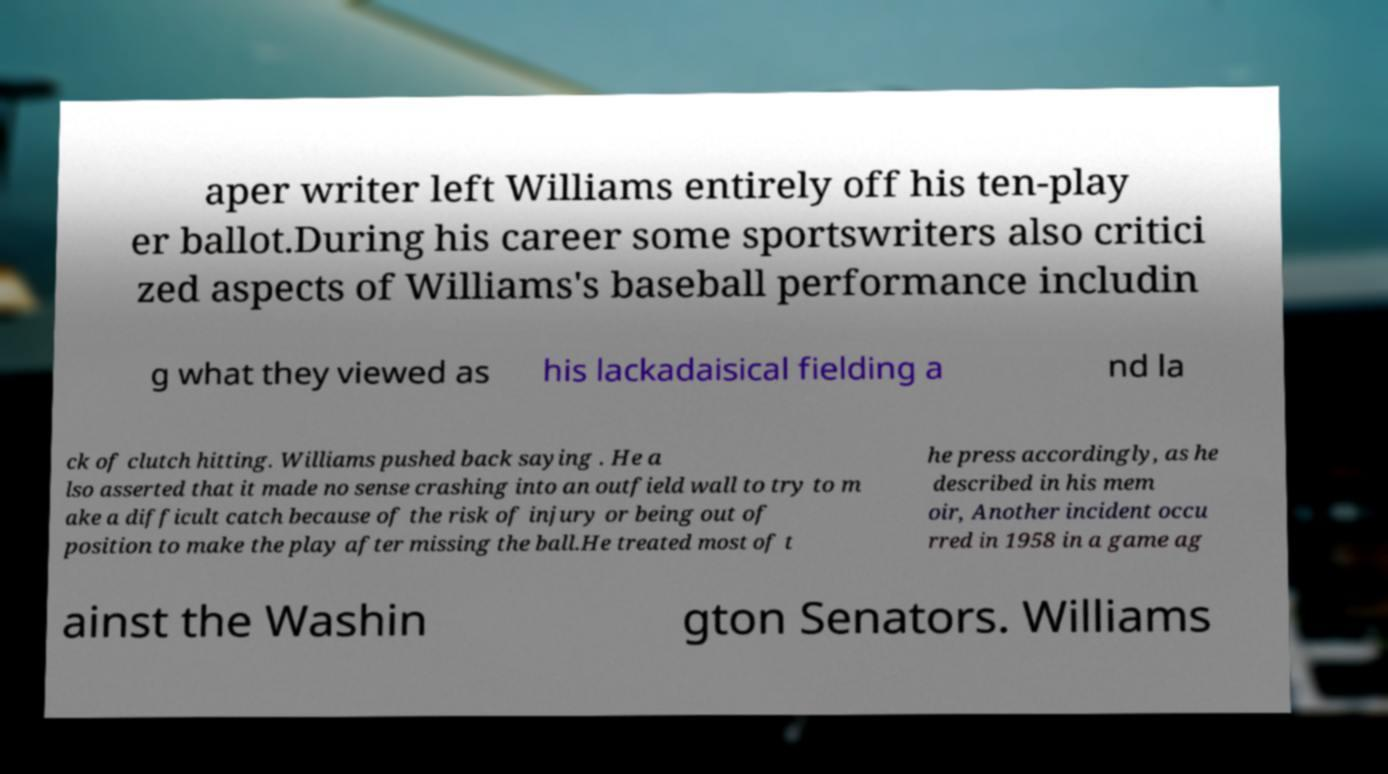Could you extract and type out the text from this image? aper writer left Williams entirely off his ten-play er ballot.During his career some sportswriters also critici zed aspects of Williams's baseball performance includin g what they viewed as his lackadaisical fielding a nd la ck of clutch hitting. Williams pushed back saying . He a lso asserted that it made no sense crashing into an outfield wall to try to m ake a difficult catch because of the risk of injury or being out of position to make the play after missing the ball.He treated most of t he press accordingly, as he described in his mem oir, Another incident occu rred in 1958 in a game ag ainst the Washin gton Senators. Williams 